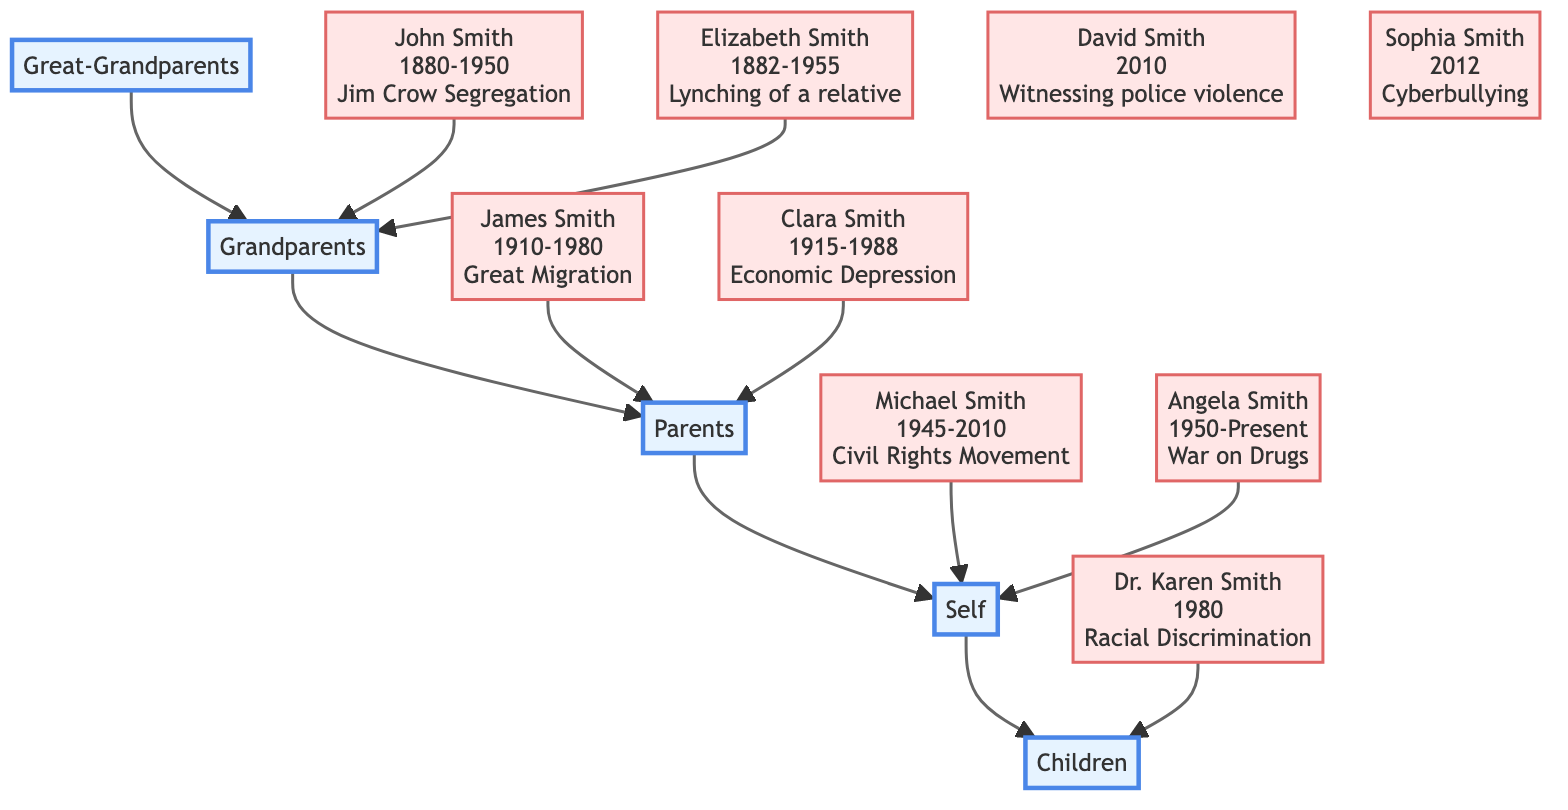What trauma event did John Smith experience? The diagram indicates that John Smith's trauma event was "Jim Crow Segregation." This information is found by locating the node for John Smith and noting the text associated with his individual entry.
Answer: Jim Crow Segregation How many generations are represented in the diagram? There are five generations displayed in the diagram: Great-Grandparents, Grandparents, Parents, Self, and Children. This can be counted by identifying each generation label in the diagram's structure.
Answer: 5 What was the effect of the Civil Rights Movement on Michael Smith's family? The diagram specifies that the effect of the Civil Rights Movement on Michael Smith's family was "Activism, intergenerational stress, exposure to violence." This is found by examining the node for Michael Smith and reading the associated effect on family.
Answer: Activism, intergenerational stress, exposure to violence Which child experienced trauma from witnessing police violence? The diagram shows that David Smith, who was born in 2010, experienced trauma from "Witnessing police violence." This can be answered by finding the node for David Smith and examining the trauma event noted next to his name.
Answer: David Smith How did the economic depression affect Clara Smith's family? According to the diagram, the economic depression affected Clara Smith's family by causing "Chronic financial stress, emphasis on frugality, limited access to healthcare." This is found by accessing Clara Smith's node and identifying her associated family effects.
Answer: Chronic financial stress, emphasis on frugality, limited access to healthcare Which generation did Dr. Karen Smith belong to? Dr. Karen Smith belongs to the "Self" generation, which is indicated by her position in the diagram directly under the "Parents" generation. This can be determined by following the generational flow from Parents to Self.
Answer: Self What was the trauma event associated with Angela Smith? The diagram indicates that Angela Smith's trauma event was the "War on Drugs." This can be verified by locating the node for Angela Smith and reviewing the trauma event presented next to her name.
Answer: War on Drugs Who were the parents of David Smith? The diagram shows that David Smith's parents are Dr. Karen Smith and an unnamed parent, Angela Smith being his mother from the "Parents" generation. To answer this, one would locate the Children generation and trace back to the associated individuals in the Self generation.
Answer: Dr. Karen Smith, Angela Smith What demographic was affected by the Great Migration? James Smith is identified as experiencing the "Great Migration." This can be confirmed by navigating to the Grandparents generation and locating James Smith's node for the associated trauma event.
Answer: James Smith 